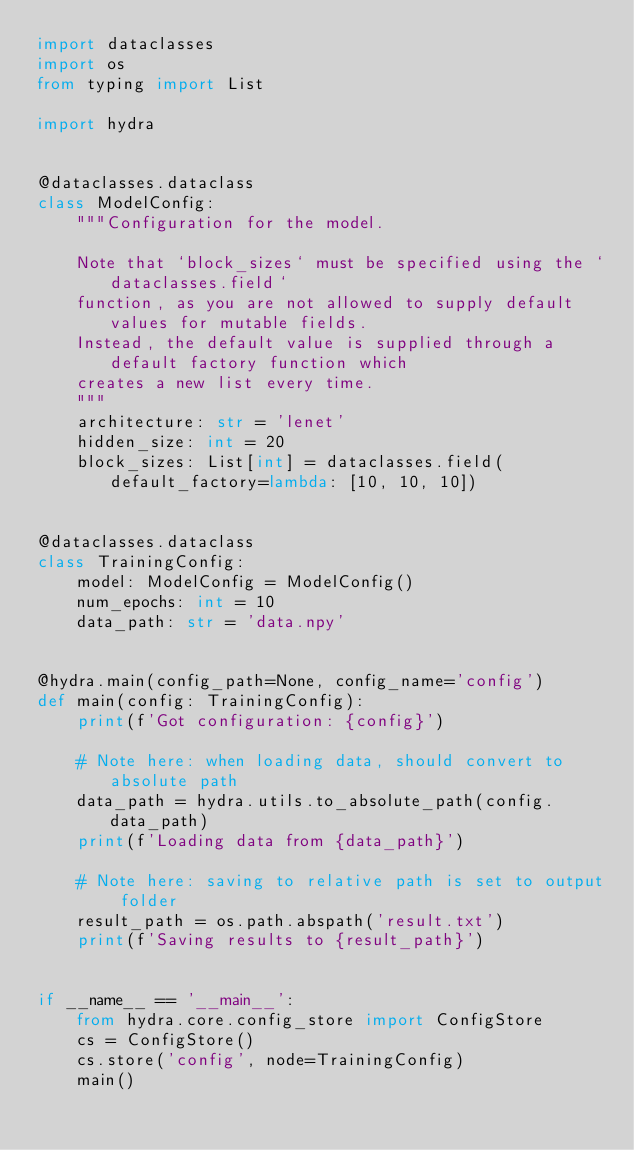Convert code to text. <code><loc_0><loc_0><loc_500><loc_500><_Python_>import dataclasses
import os
from typing import List

import hydra


@dataclasses.dataclass
class ModelConfig:
    """Configuration for the model.

    Note that `block_sizes` must be specified using the `dataclasses.field`
    function, as you are not allowed to supply default values for mutable fields.
    Instead, the default value is supplied through a default factory function which
    creates a new list every time.
    """
    architecture: str = 'lenet'
    hidden_size: int = 20
    block_sizes: List[int] = dataclasses.field(default_factory=lambda: [10, 10, 10])


@dataclasses.dataclass
class TrainingConfig:
    model: ModelConfig = ModelConfig()
    num_epochs: int = 10
    data_path: str = 'data.npy'


@hydra.main(config_path=None, config_name='config')
def main(config: TrainingConfig):
    print(f'Got configuration: {config}')

    # Note here: when loading data, should convert to absolute path
    data_path = hydra.utils.to_absolute_path(config.data_path)
    print(f'Loading data from {data_path}')

    # Note here: saving to relative path is set to output folder
    result_path = os.path.abspath('result.txt')
    print(f'Saving results to {result_path}')


if __name__ == '__main__':
    from hydra.core.config_store import ConfigStore
    cs = ConfigStore()
    cs.store('config', node=TrainingConfig)
    main()
</code> 